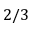Convert formula to latex. <formula><loc_0><loc_0><loc_500><loc_500>2 / 3</formula> 